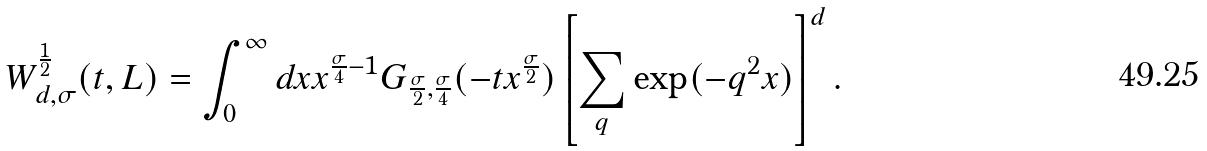Convert formula to latex. <formula><loc_0><loc_0><loc_500><loc_500>W _ { d , \sigma } ^ { \frac { 1 } { 2 } } ( t , L ) = \int _ { 0 } ^ { \infty } d x x ^ { \frac { \sigma } { 4 } - 1 } G _ { \frac { \sigma } { 2 } , \frac { \sigma } { 4 } } ( - t x ^ { \frac { \sigma } { 2 } } ) \left [ \sum _ { q } \exp ( - q ^ { 2 } x ) \right ] ^ { d } .</formula> 